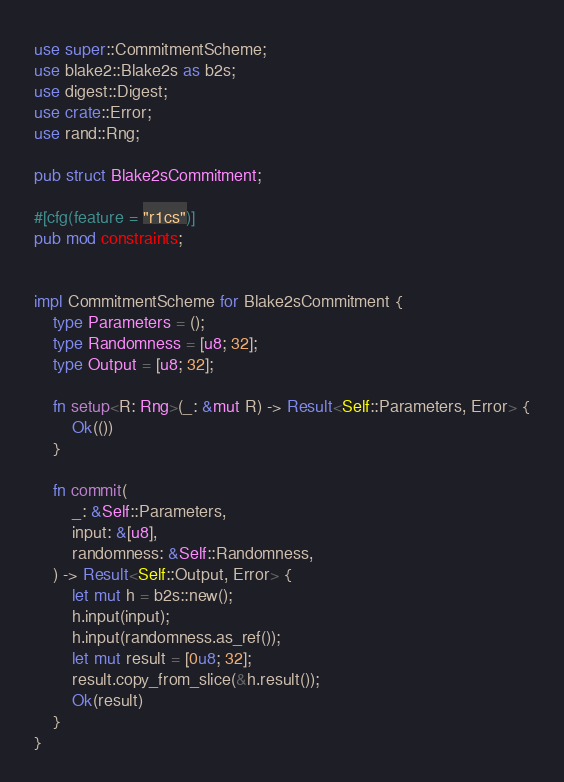Convert code to text. <code><loc_0><loc_0><loc_500><loc_500><_Rust_>use super::CommitmentScheme;
use blake2::Blake2s as b2s;
use digest::Digest;
use crate::Error;
use rand::Rng;

pub struct Blake2sCommitment;

#[cfg(feature = "r1cs")]
pub mod constraints;


impl CommitmentScheme for Blake2sCommitment {
    type Parameters = ();
    type Randomness = [u8; 32];
    type Output = [u8; 32];

    fn setup<R: Rng>(_: &mut R) -> Result<Self::Parameters, Error> {
        Ok(())
    }

    fn commit(
        _: &Self::Parameters,
        input: &[u8],
        randomness: &Self::Randomness,
    ) -> Result<Self::Output, Error> {
        let mut h = b2s::new();
        h.input(input);
        h.input(randomness.as_ref());
        let mut result = [0u8; 32];
        result.copy_from_slice(&h.result());
        Ok(result)
    }
}
</code> 